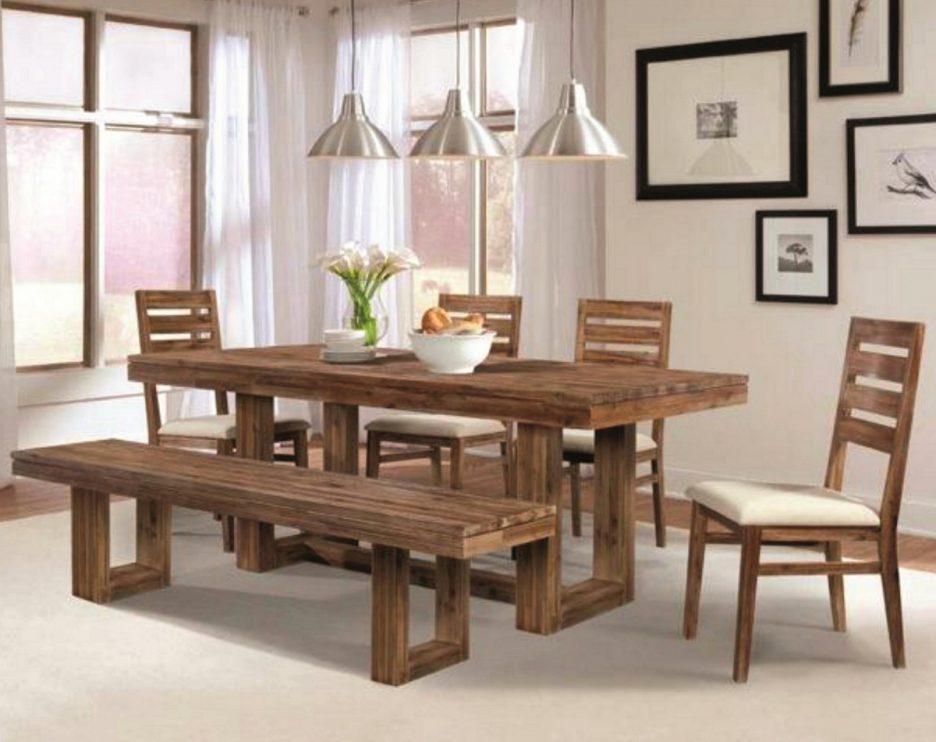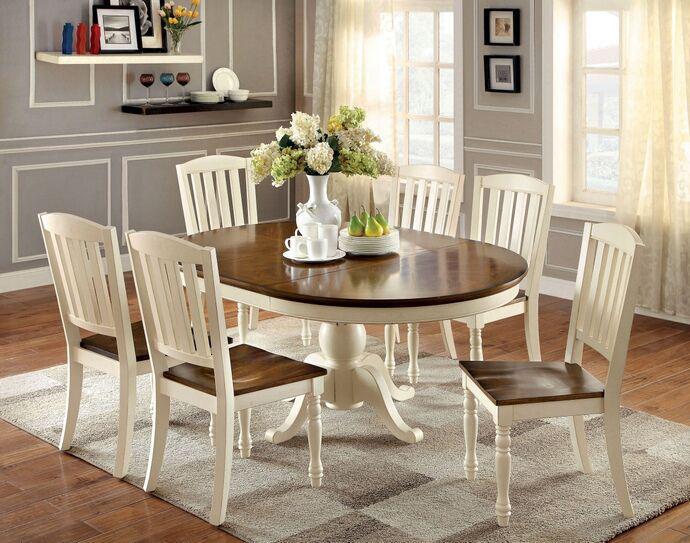The first image is the image on the left, the second image is the image on the right. Considering the images on both sides, is "In one of the images, two different styles of seating are available around a single table." valid? Answer yes or no. Yes. The first image is the image on the left, the second image is the image on the right. Evaluate the accuracy of this statement regarding the images: "One image shows a brown topped white table with six white chairs with brown seats around it, and the other image shows a non-round table with a bench on one side and at least three chairs with multiple rails across the back.". Is it true? Answer yes or no. Yes. 